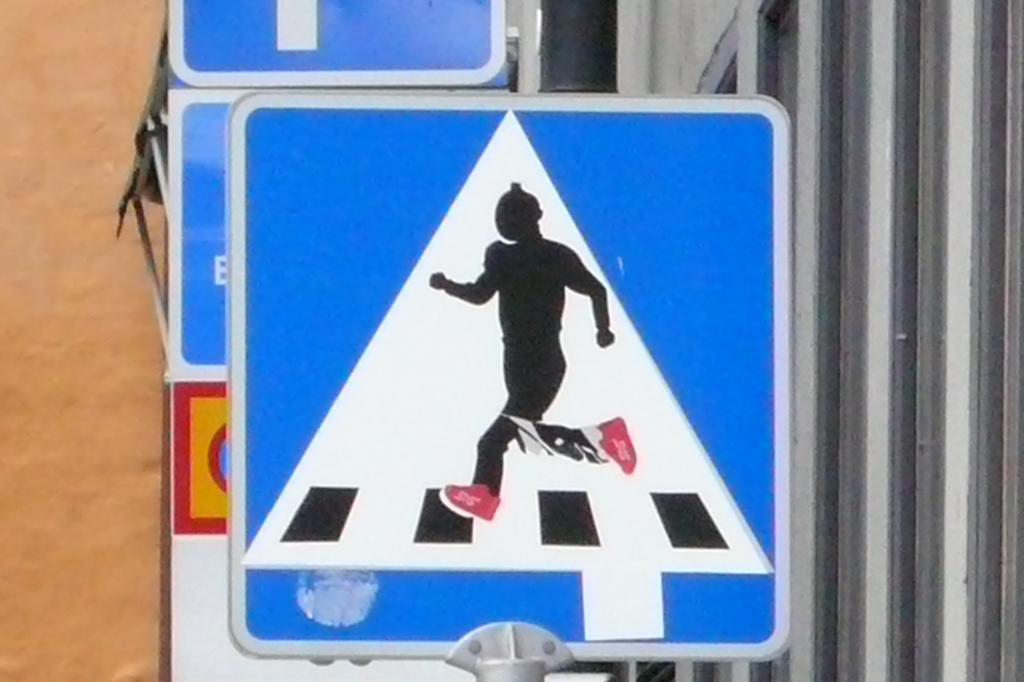What is the main subject in the center of the image? There is a sign pole in the center of the image. What type of clouds can be seen hanging from the sign pole in the image? There are no clouds present in the image, as it features a sign pole without any clouds. 